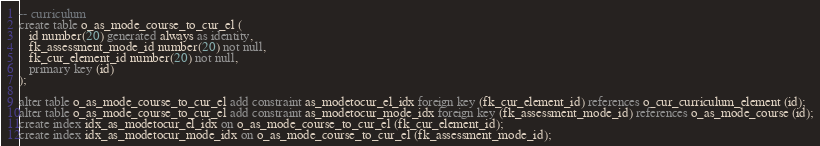Convert code to text. <code><loc_0><loc_0><loc_500><loc_500><_SQL_>-- curriculum
create table o_as_mode_course_to_cur_el (
   id number(20) generated always as identity,
   fk_assessment_mode_id number(20) not null,
   fk_cur_element_id number(20) not null,
   primary key (id)
);

alter table o_as_mode_course_to_cur_el add constraint as_modetocur_el_idx foreign key (fk_cur_element_id) references o_cur_curriculum_element (id);
alter table o_as_mode_course_to_cur_el add constraint as_modetocur_mode_idx foreign key (fk_assessment_mode_id) references o_as_mode_course (id);
create index idx_as_modetocur_el_idx on o_as_mode_course_to_cur_el (fk_cur_element_id);
create index idx_as_modetocur_mode_idx on o_as_mode_course_to_cur_el (fk_assessment_mode_id);

</code> 